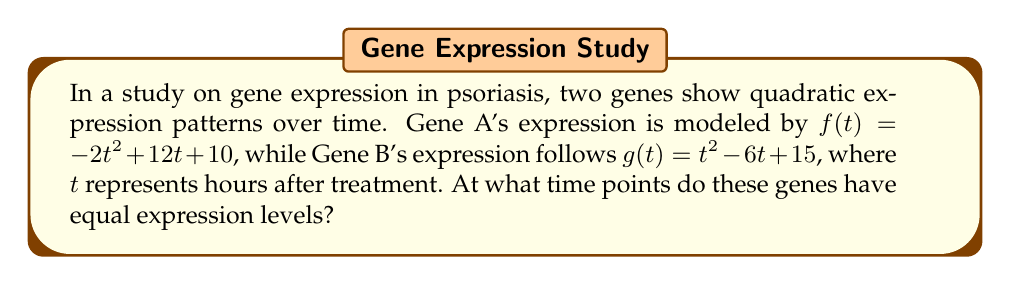Can you solve this math problem? To find the intersection points of the gene expression curves, we need to solve the equation $f(t) = g(t)$.

1) Set up the equation:
   $-2t^2 + 12t + 10 = t^2 - 6t + 15$

2) Rearrange to standard form:
   $-2t^2 + 12t + 10 - (t^2 - 6t + 15) = 0$
   $-3t^2 + 18t - 5 = 0$

3) Divide all terms by -1 to make the leading coefficient positive:
   $3t^2 - 18t + 5 = 0$

4) Use the quadratic formula: $t = \frac{-b \pm \sqrt{b^2 - 4ac}}{2a}$
   Where $a = 3$, $b = -18$, and $c = 5$

5) Substitute into the formula:
   $t = \frac{18 \pm \sqrt{(-18)^2 - 4(3)(5)}}{2(3)}$
   $= \frac{18 \pm \sqrt{324 - 60}}{6}$
   $= \frac{18 \pm \sqrt{264}}{6}$
   $= \frac{18 \pm 2\sqrt{66}}{6}$

6) Simplify:
   $t = 3 \pm \frac{\sqrt{66}}{3}$

7) Calculate the two solutions:
   $t_1 = 3 + \frac{\sqrt{66}}{3} \approx 5.70$ hours
   $t_2 = 3 - \frac{\sqrt{66}}{3} \approx 0.30$ hours
Answer: $t = 3 \pm \frac{\sqrt{66}}{3}$ hours 